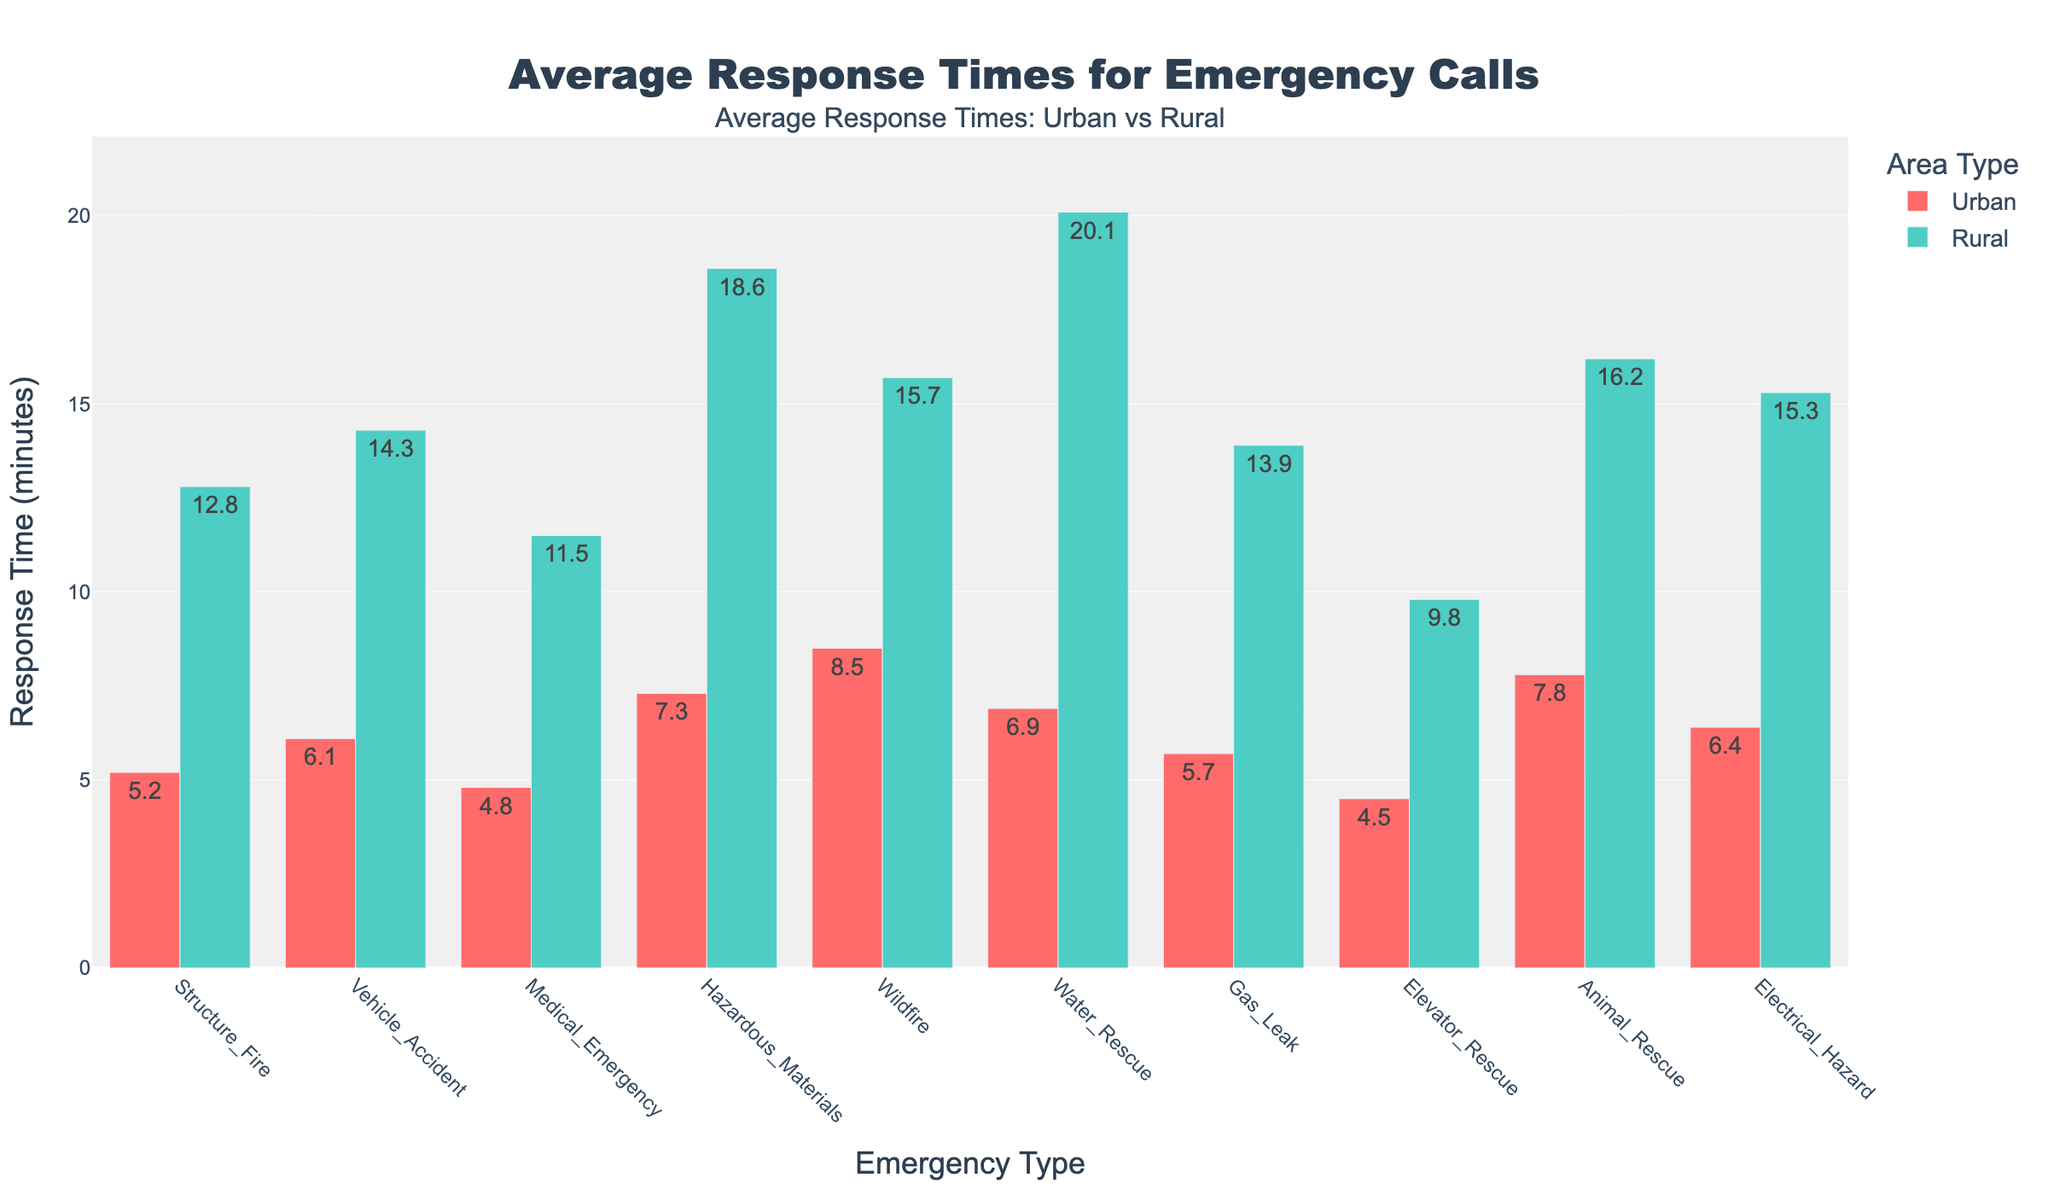What is the response time difference between Urban and Rural areas for Vehicle Accidents? To find the response time difference, subtract the Urban response time from the Rural response time for Vehicle Accidents: 14.3 - 6.1 = 8.2 minutes
Answer: 8.2 minutes Which emergency type has the longest average response time in Rural areas? By examining the heights of the bars for Rural areas, the longest bar corresponds to Water Rescue with an average response time of 20.1 minutes
Answer: Water Rescue Are response times generally faster in Urban or Rural areas? By comparing the heights of all the bars for Urban and Rural areas, it is clear that Urban bars are consistently shorter, indicating faster response times on average
Answer: Urban areas What is the combined response time for Urban areas for Medical Emergencies and Gas Leaks? Add the response times for Urban areas for Medical Emergencies and Gas Leaks: 4.8 + 5.7 = 10.5 minutes
Answer: 10.5 minutes For which emergency type is the difference between Urban and Rural response times the smallest? Calculate the differences for each emergency type, and identify that Elevator Rescue has the smallest difference: 9.8 - 4.5 = 5.3 minutes
Answer: Elevator Rescue How much longer does it take on average to respond to Wildfires in Rural areas compared to Urban areas? Subtract the Urban response time from the Rural response time for Wildfires: 15.7 - 8.5 = 7.2 minutes
Answer: 7.2 minutes Which emergency type has a nearly equal response time in both Urban and Rural areas? By examining the bars, none of the emergency types have nearly equal response times; Elevator Rescue has the closest with a difference of 5.3 minutes, but still noticeable
Answer: None What is the average response time for Hazmat emergencies in both Urban and Rural areas combined? Calculate the average by adding Hazmat response times for both areas and dividing by 2: (7.3 + 18.6) / 2 = 12.95 minutes
Answer: 12.95 minutes What emergency type has the shortest average response time in Urban areas? By examining the heights of the Urban bars, the shortest bar corresponds to Elevator Rescue with an average response time of 4.5 minutes
Answer: Elevator Rescue 